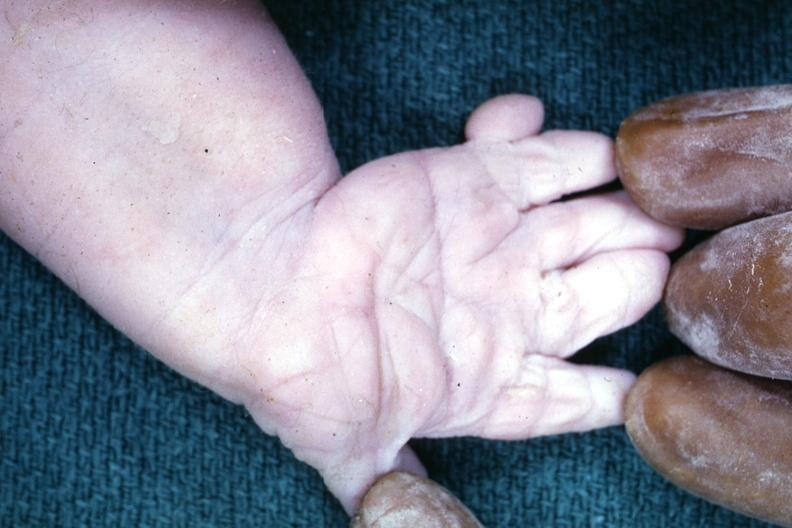what are present?
Answer the question using a single word or phrase. Extremities 